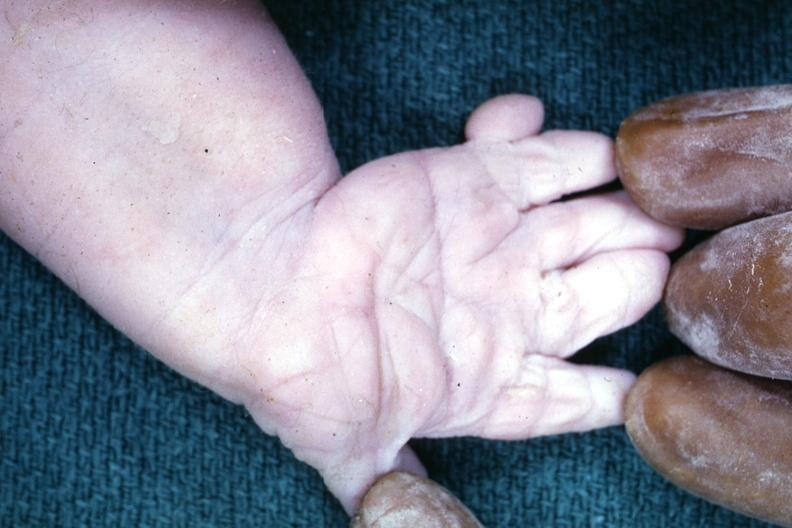what are present?
Answer the question using a single word or phrase. Extremities 